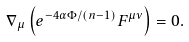Convert formula to latex. <formula><loc_0><loc_0><loc_500><loc_500>\nabla _ { \mu } \left ( e ^ { - 4 \alpha \Phi / ( n - 1 ) } F ^ { \mu \nu } \right ) = 0 .</formula> 